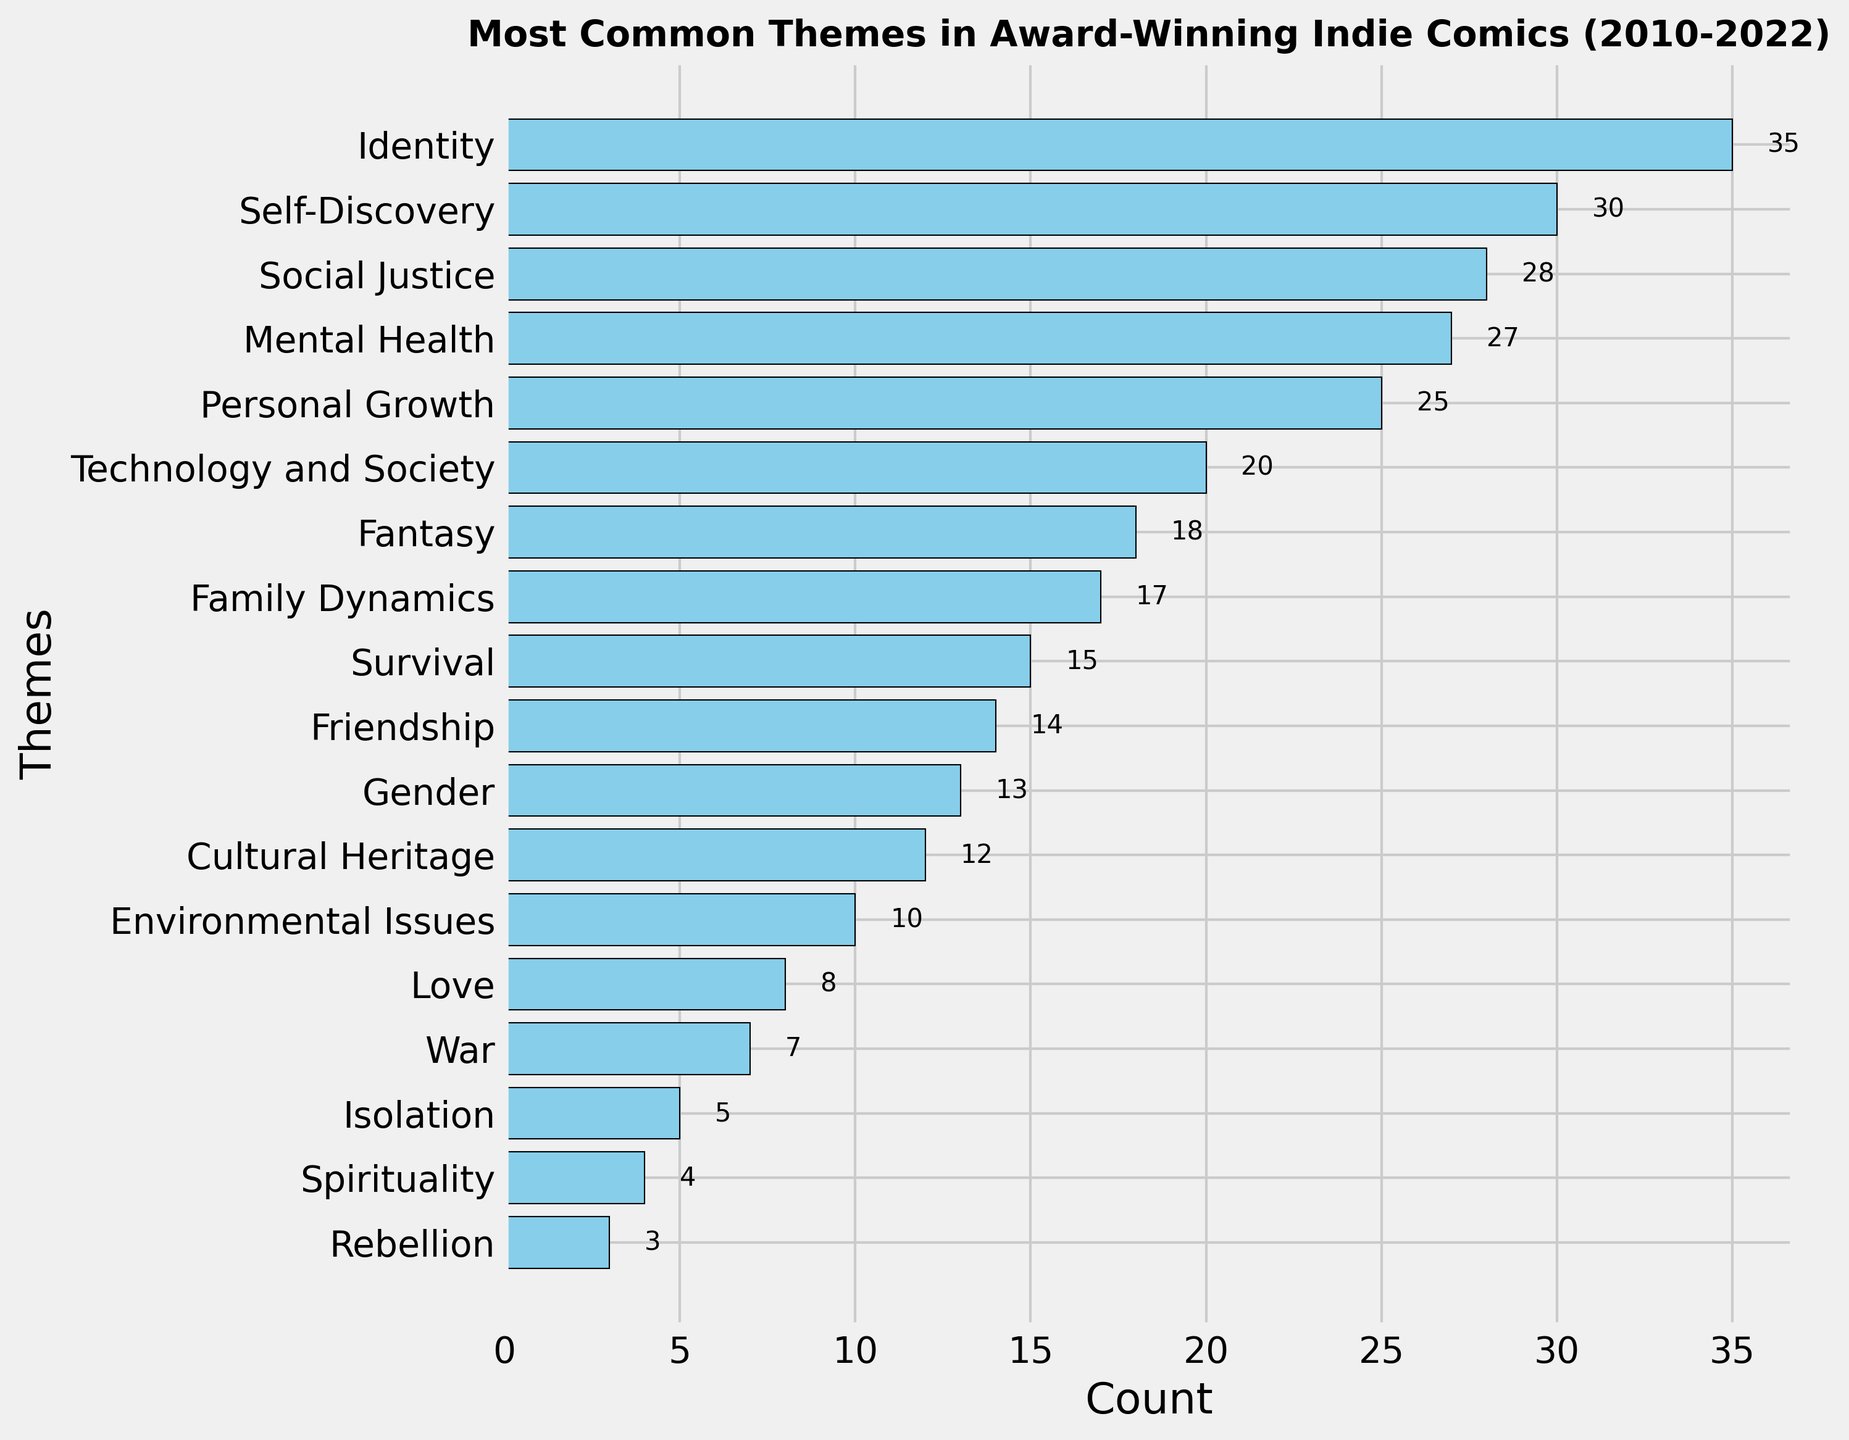Which theme is the most common in award-winning indie comics from 2010 to 2022? The theme with the highest count is at the top of the y-axis since the y-axis is inverted. In this case, "Identity" appears at the top with a count of 35.
Answer: Identity How many more comics feature the theme "Identity" compared to "Isolation"? The count for "Identity" is 35 and for "Isolation" is 5. The difference is 35 - 5 = 30.
Answer: 30 Which themes have a count higher than 20? The themes with counts higher than 20 can be observed by looking at the horizontal bars extending past the 20 mark. They are "Identity," "Self-Discovery," "Social Justice," "Mental Health," and "Personal Growth."
Answer: Identity, Self-Discovery, Social Justice, Mental Health, Personal Growth What is the total count of comics featuring the themes "Family Dynamics," "Friendship," and "Gender"? The counts for "Family Dynamics," "Friendship," and "Gender" are 17, 14, and 13 respectively. Adding them gives 17 + 14 + 13 = 44.
Answer: 44 Is the number of comics featuring "Fantasy" greater than those featuring "Technology and Society"? The count for "Fantasy" is 18 and for "Technology and Society" is 20. Since 18 < 20, the number of comics featuring "Fantasy" is not greater.
Answer: No Which theme appears immediately below "Personal Growth" in the bar chart? In the inverted y-axis, the theme immediately below "Personal Growth" is "Technology and Society."
Answer: Technology and Society What is the average count of comics for the themes "Environmental Issues," "War," and "Isolation"? The counts are 10, 7, and 5 respectively. The sum is 10 + 7 + 5 = 22. Dividing by 3 gives 22 / 3 ≈ 7.33.
Answer: 7.33 How many themes have counts between 10 and 20, inclusive? Observing the bar lengths, the themes with counts from 10 to 20 are "Technology and Society," "Fantasy," "Family Dynamics," "Survival," "Friendship," "Gender," and "Cultural Heritage," making a total of 7.
Answer: 7 What is the total count of comics that feature themes related to personal and social aspects, specifically "Identity," "Self-Discovery," "Social Justice," "Mental Health," and "Personal Growth"? Adding the counts for these themes gives 35 (Identity) + 30 (Self-Discovery) + 28 (Social Justice) + 27 (Mental Health) + 25 (Personal Growth) = 145.
Answer: 145 From the given themes, which one is the least common and how many comics does it feature? The least common theme will be at the bottom of the y-axis, which is "Rebellion" with a count of 3.
Answer: Rebellion, 3 